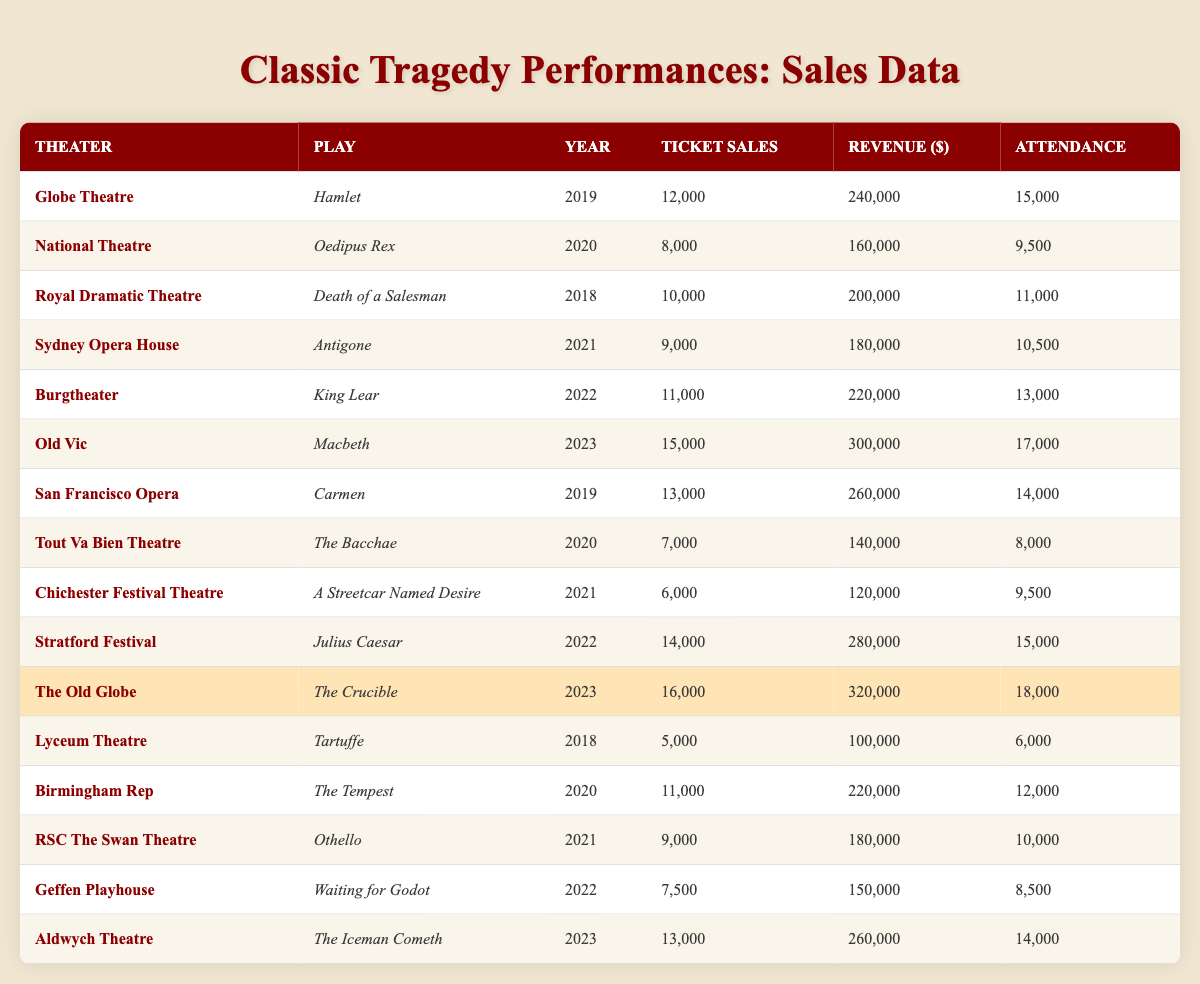What is the total ticket sales for "Macbeth" at the Old Vic? The table shows that the ticket sales for "Macbeth" at the Old Vic in 2023 is 15,000.
Answer: 15,000 Which theater had the highest revenue in 2023? By comparing the revenue figures for all theaters in 2023, The Old Globe has the highest revenue of 320,000.
Answer: The Old Globe What is the average attendance for the plays in 2022? The attendance figures for 2022 are 13,000 (King Lear), 15,000 (Julius Caesar), and 8,500 (Waiting for Godot). The total attendance is 36,500, and there are 3 plays, so the average attendance is 36,500 / 3 = 12,166.67, which rounds to 12,167.
Answer: 12,167 Did "Carmen" achieve over 12,000 ticket sales in 2019? The table shows that "Carmen" had 13,000 ticket sales in 2019, which is indeed over 12,000.
Answer: Yes Which play had the lowest ticket sales in the given data? Looking through the ticket sales figures, "Tartuffe" had the lowest ticket sales at 5,000.
Answer: Tartuffe What was the attendance for "Oedipus Rex" at the National Theatre in 2020? The table indicates that the attendance for "Oedipus Rex" in 2020 was 9,500.
Answer: 9,500 Calculate the total revenue from plays performed in 2019. The revenue from plays in 2019 includes 240,000 (Hamlet) and 260,000 (Carmen), which adds up to 500,000.
Answer: 500,000 Which theater's performance in 2021 had attendance less than 11,000? In 2021, the Chichester Festival Theatre's performance of "A Streetcar Named Desire" had an attendance figure of 9,500, which is less than 11,000.
Answer: Chichester Festival Theatre What play had more than 10,000 ticket sales in 2020? The data shows that "The Tempest" at Birmingham Rep had 11,000 ticket sales, which exceeds 10,000.
Answer: The Tempest What is the difference between the highest and lowest ticket sales in 2021? The highest ticket sales in 2021 were 9,000 (Antigone) and the lowest were 6,000 (A Streetcar Named Desire), leading to a difference of 3,000.
Answer: 3,000 